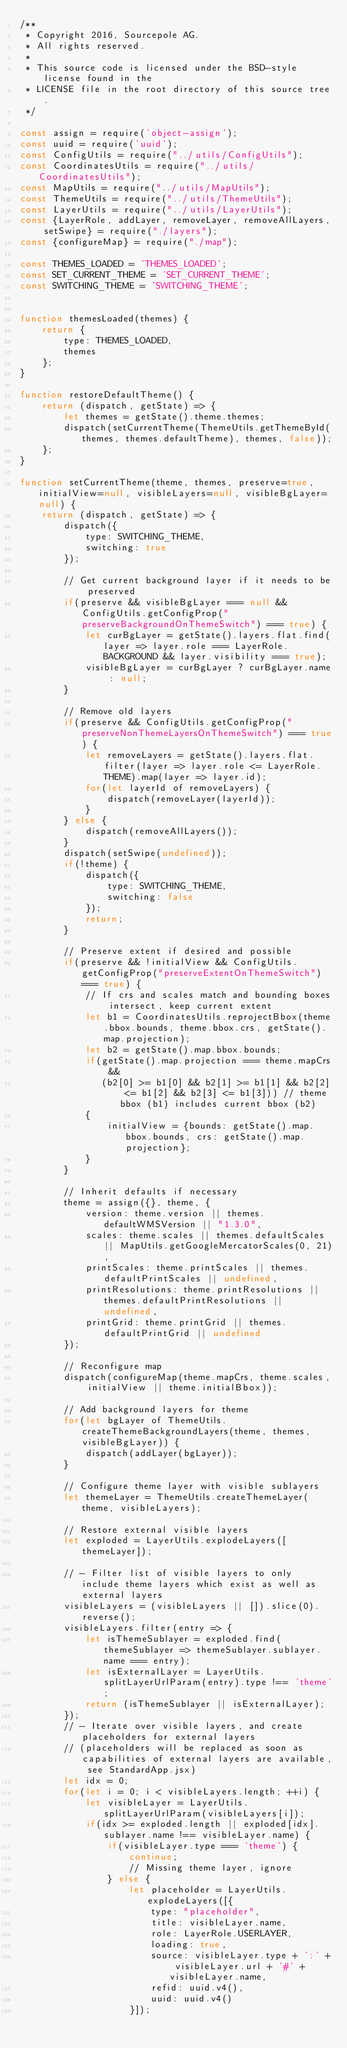Convert code to text. <code><loc_0><loc_0><loc_500><loc_500><_JavaScript_>/**
 * Copyright 2016, Sourcepole AG.
 * All rights reserved.
 *
 * This source code is licensed under the BSD-style license found in the
 * LICENSE file in the root directory of this source tree.
 */

const assign = require('object-assign');
const uuid = require('uuid');
const ConfigUtils = require("../utils/ConfigUtils");
const CoordinatesUtils = require("../utils/CoordinatesUtils");
const MapUtils = require("../utils/MapUtils");
const ThemeUtils = require("../utils/ThemeUtils");
const LayerUtils = require("../utils/LayerUtils");
const {LayerRole, addLayer, removeLayer, removeAllLayers, setSwipe} = require("./layers");
const {configureMap} = require("./map");

const THEMES_LOADED = 'THEMES_LOADED';
const SET_CURRENT_THEME = 'SET_CURRENT_THEME';
const SWITCHING_THEME = 'SWITCHING_THEME';


function themesLoaded(themes) {
    return {
        type: THEMES_LOADED,
        themes
    };
}

function restoreDefaultTheme() {
    return (dispatch, getState) => {
        let themes = getState().theme.themes;
        dispatch(setCurrentTheme(ThemeUtils.getThemeById(themes, themes.defaultTheme), themes, false));
    };
}

function setCurrentTheme(theme, themes, preserve=true, initialView=null, visibleLayers=null, visibleBgLayer=null) {
    return (dispatch, getState) => {
        dispatch({
            type: SWITCHING_THEME,
            switching: true
        });

        // Get current background layer if it needs to be preserved
        if(preserve && visibleBgLayer === null && ConfigUtils.getConfigProp("preserveBackgroundOnThemeSwitch") === true) {
            let curBgLayer = getState().layers.flat.find(layer => layer.role === LayerRole.BACKGROUND && layer.visibility === true);
            visibleBgLayer = curBgLayer ? curBgLayer.name : null;
        }

        // Remove old layers
        if(preserve && ConfigUtils.getConfigProp("preserveNonThemeLayersOnThemeSwitch") === true) {
            let removeLayers = getState().layers.flat.filter(layer => layer.role <= LayerRole.THEME).map(layer => layer.id);
            for(let layerId of removeLayers) {
                dispatch(removeLayer(layerId));
            }
        } else {
            dispatch(removeAllLayers());
        }
        dispatch(setSwipe(undefined));
        if(!theme) {
            dispatch({
                type: SWITCHING_THEME,
                switching: false
            });
            return;
        }

        // Preserve extent if desired and possible
        if(preserve && !initialView && ConfigUtils.getConfigProp("preserveExtentOnThemeSwitch") === true) {
            // If crs and scales match and bounding boxes intersect, keep current extent
            let b1 = CoordinatesUtils.reprojectBbox(theme.bbox.bounds, theme.bbox.crs, getState().map.projection);
            let b2 = getState().map.bbox.bounds;
            if(getState().map.projection === theme.mapCrs &&
               (b2[0] >= b1[0] && b2[1] >= b1[1] && b2[2] <= b1[2] && b2[3] <= b1[3])) // theme bbox (b1) includes current bbox (b2)
            {
                initialView = {bounds: getState().map.bbox.bounds, crs: getState().map.projection};
            }
        }

        // Inherit defaults if necessary
        theme = assign({}, theme, {
            version: theme.version || themes.defaultWMSVersion || "1.3.0",
            scales: theme.scales || themes.defaultScales || MapUtils.getGoogleMercatorScales(0, 21),
            printScales: theme.printScales || themes.defaultPrintScales || undefined,
            printResolutions: theme.printResolutions || themes.defaultPrintResolutions || undefined,
            printGrid: theme.printGrid || themes.defaultPrintGrid || undefined
        });

        // Reconfigure map
        dispatch(configureMap(theme.mapCrs, theme.scales, initialView || theme.initialBbox));

        // Add background layers for theme
        for(let bgLayer of ThemeUtils.createThemeBackgroundLayers(theme, themes, visibleBgLayer)) {
            dispatch(addLayer(bgLayer));
        }

        // Configure theme layer with visible sublayers
        let themeLayer = ThemeUtils.createThemeLayer(theme, visibleLayers);

        // Restore external visible layers
        let exploded = LayerUtils.explodeLayers([themeLayer]);

        // - Filter list of visible layers to only include theme layers which exist as well as external layers
        visibleLayers = (visibleLayers || []).slice(0).reverse();
        visibleLayers.filter(entry => {
            let isThemeSublayer = exploded.find(themeSublayer => themeSublayer.sublayer.name === entry);
            let isExternalLayer = LayerUtils.splitLayerUrlParam(entry).type !== 'theme';
            return (isThemeSublayer || isExternalLayer);
        });
        // - Iterate over visible layers, and create placeholders for external layers
        // (placeholders will be replaced as soon as capabilities of external layers are available, see StandardApp.jsx)
        let idx = 0;
        for(let i = 0; i < visibleLayers.length; ++i) {
            let visibleLayer = LayerUtils.splitLayerUrlParam(visibleLayers[i]);
            if(idx >= exploded.length || exploded[idx].sublayer.name !== visibleLayer.name) {
                if(visibleLayer.type === 'theme') {
                    continue;
                    // Missing theme layer, ignore
                } else {
                    let placeholder = LayerUtils.explodeLayers([{
                        type: "placeholder",
                        title: visibleLayer.name,
                        role: LayerRole.USERLAYER,
                        loading: true,
                        source: visibleLayer.type + ':' + visibleLayer.url + '#' + visibleLayer.name,
                        refid: uuid.v4(),
                        uuid: uuid.v4()
                    }]);</code> 